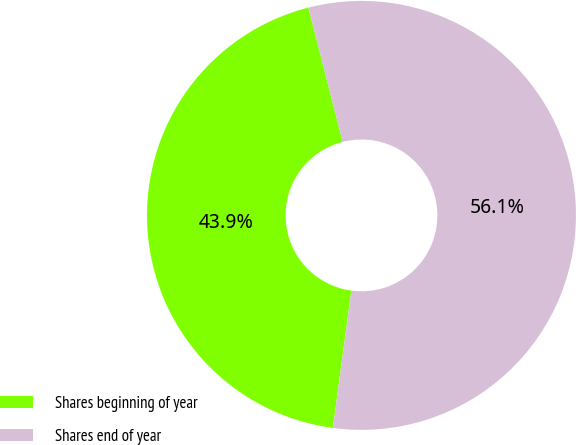Convert chart to OTSL. <chart><loc_0><loc_0><loc_500><loc_500><pie_chart><fcel>Shares beginning of year<fcel>Shares end of year<nl><fcel>43.89%<fcel>56.11%<nl></chart> 